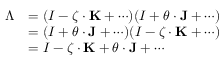Convert formula to latex. <formula><loc_0><loc_0><loc_500><loc_500>{ \begin{array} { r l } { \Lambda } & { = ( I - { \zeta } \cdot K + \cdots ) ( I + { \theta } \cdot J + \cdots ) } \\ & { = ( I + { \theta } \cdot J + \cdots ) ( I - { \zeta } \cdot K + \cdots ) } \\ & { = I - { \zeta } \cdot K + { \theta } \cdot J + \cdots } \end{array} }</formula> 